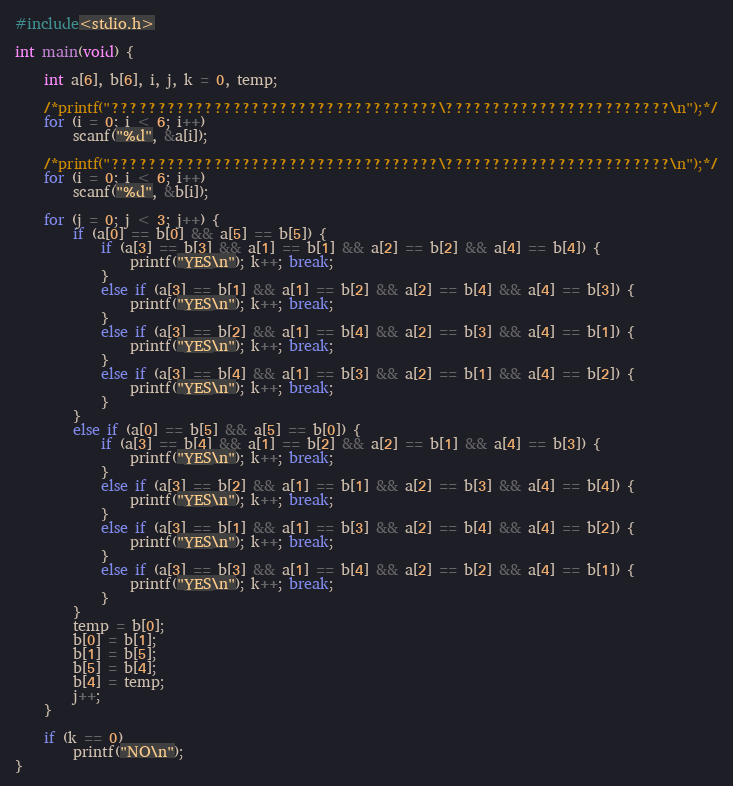<code> <loc_0><loc_0><loc_500><loc_500><_C_>#include<stdio.h>

int main(void) {

	int a[6], b[6], i, j, k = 0, temp;

	/*printf("???????????????????????????????????\????????????????????????\n");*/
	for (i = 0; i < 6; i++)
		scanf("%d", &a[i]);

	/*printf("???????????????????????????????????\????????????????????????\n");*/
	for (i = 0; i < 6; i++)
		scanf("%d", &b[i]);

	for (j = 0; j < 3; j++) {
		if (a[0] == b[0] && a[5] == b[5]) {
			if (a[3] == b[3] && a[1] == b[1] && a[2] == b[2] && a[4] == b[4]) {
				printf("YES\n"); k++; break;
			}
			else if (a[3] == b[1] && a[1] == b[2] && a[2] == b[4] && a[4] == b[3]) {
				printf("YES\n"); k++; break;
			}
			else if (a[3] == b[2] && a[1] == b[4] && a[2] == b[3] && a[4] == b[1]) {
				printf("YES\n"); k++; break;
			}
			else if (a[3] == b[4] && a[1] == b[3] && a[2] == b[1] && a[4] == b[2]) {
				printf("YES\n"); k++; break;
			}
		}
		else if (a[0] == b[5] && a[5] == b[0]) {
			if (a[3] == b[4] && a[1] == b[2] && a[2] == b[1] && a[4] == b[3]) {
				printf("YES\n"); k++; break;
			}
			else if (a[3] == b[2] && a[1] == b[1] && a[2] == b[3] && a[4] == b[4]) {
				printf("YES\n"); k++; break;
			}
			else if (a[3] == b[1] && a[1] == b[3] && a[2] == b[4] && a[4] == b[2]) {
				printf("YES\n"); k++; break;
			}
			else if (a[3] == b[3] && a[1] == b[4] && a[2] == b[2] && a[4] == b[1]) {
				printf("YES\n"); k++; break;
			}
		}
		temp = b[0];
		b[0] = b[1];
		b[1] = b[5];
		b[5] = b[4];
		b[4] = temp;
		j++;
	}

	if (k == 0)
		printf("NO\n");
}</code> 